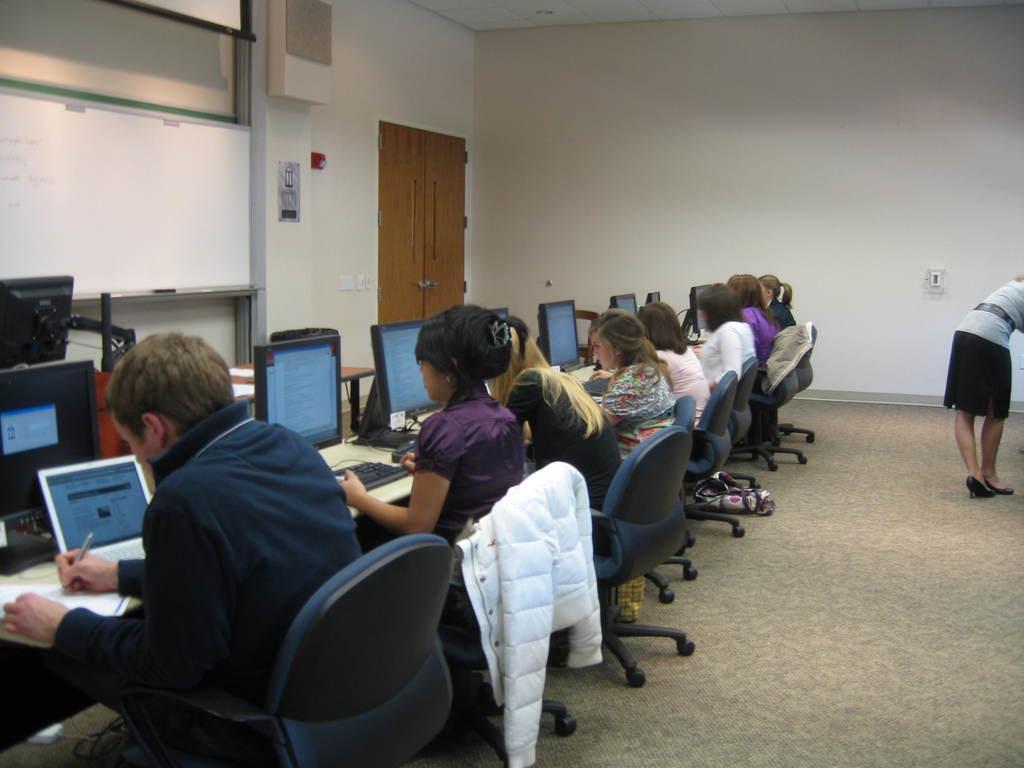How would you summarize this image in a sentence or two? In this image I can see in the middle a group of people are sitting on the chairs and working with the systems. On the right side a person is standing, it looks like an office. 